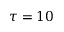<formula> <loc_0><loc_0><loc_500><loc_500>\tau = 1 0</formula> 